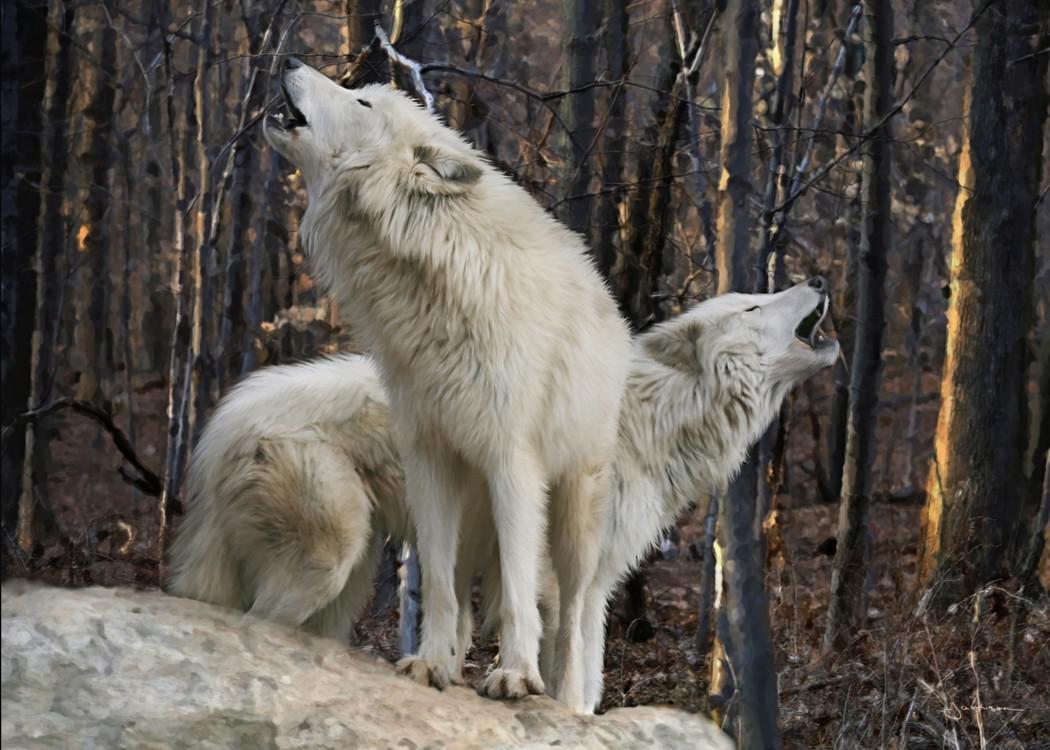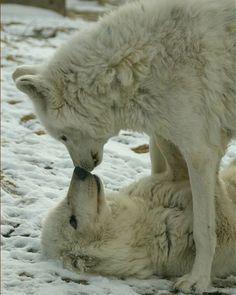The first image is the image on the left, the second image is the image on the right. Examine the images to the left and right. Is the description "All wolves are touching each other's faces in an affectionate way." accurate? Answer yes or no. No. The first image is the image on the left, the second image is the image on the right. For the images displayed, is the sentence "At least one wolf has its tongue visible in the left image." factually correct? Answer yes or no. No. 